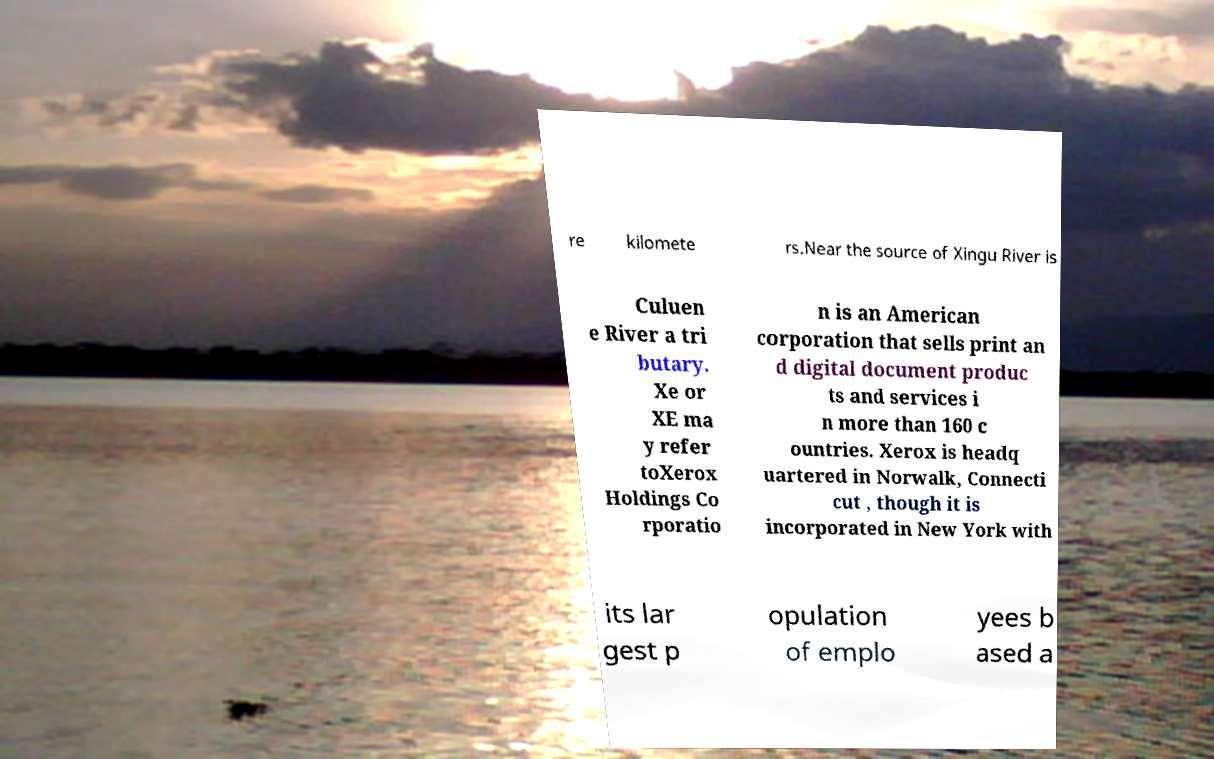Can you accurately transcribe the text from the provided image for me? re kilomete rs.Near the source of Xingu River is Culuen e River a tri butary. Xe or XE ma y refer toXerox Holdings Co rporatio n is an American corporation that sells print an d digital document produc ts and services i n more than 160 c ountries. Xerox is headq uartered in Norwalk, Connecti cut , though it is incorporated in New York with its lar gest p opulation of emplo yees b ased a 